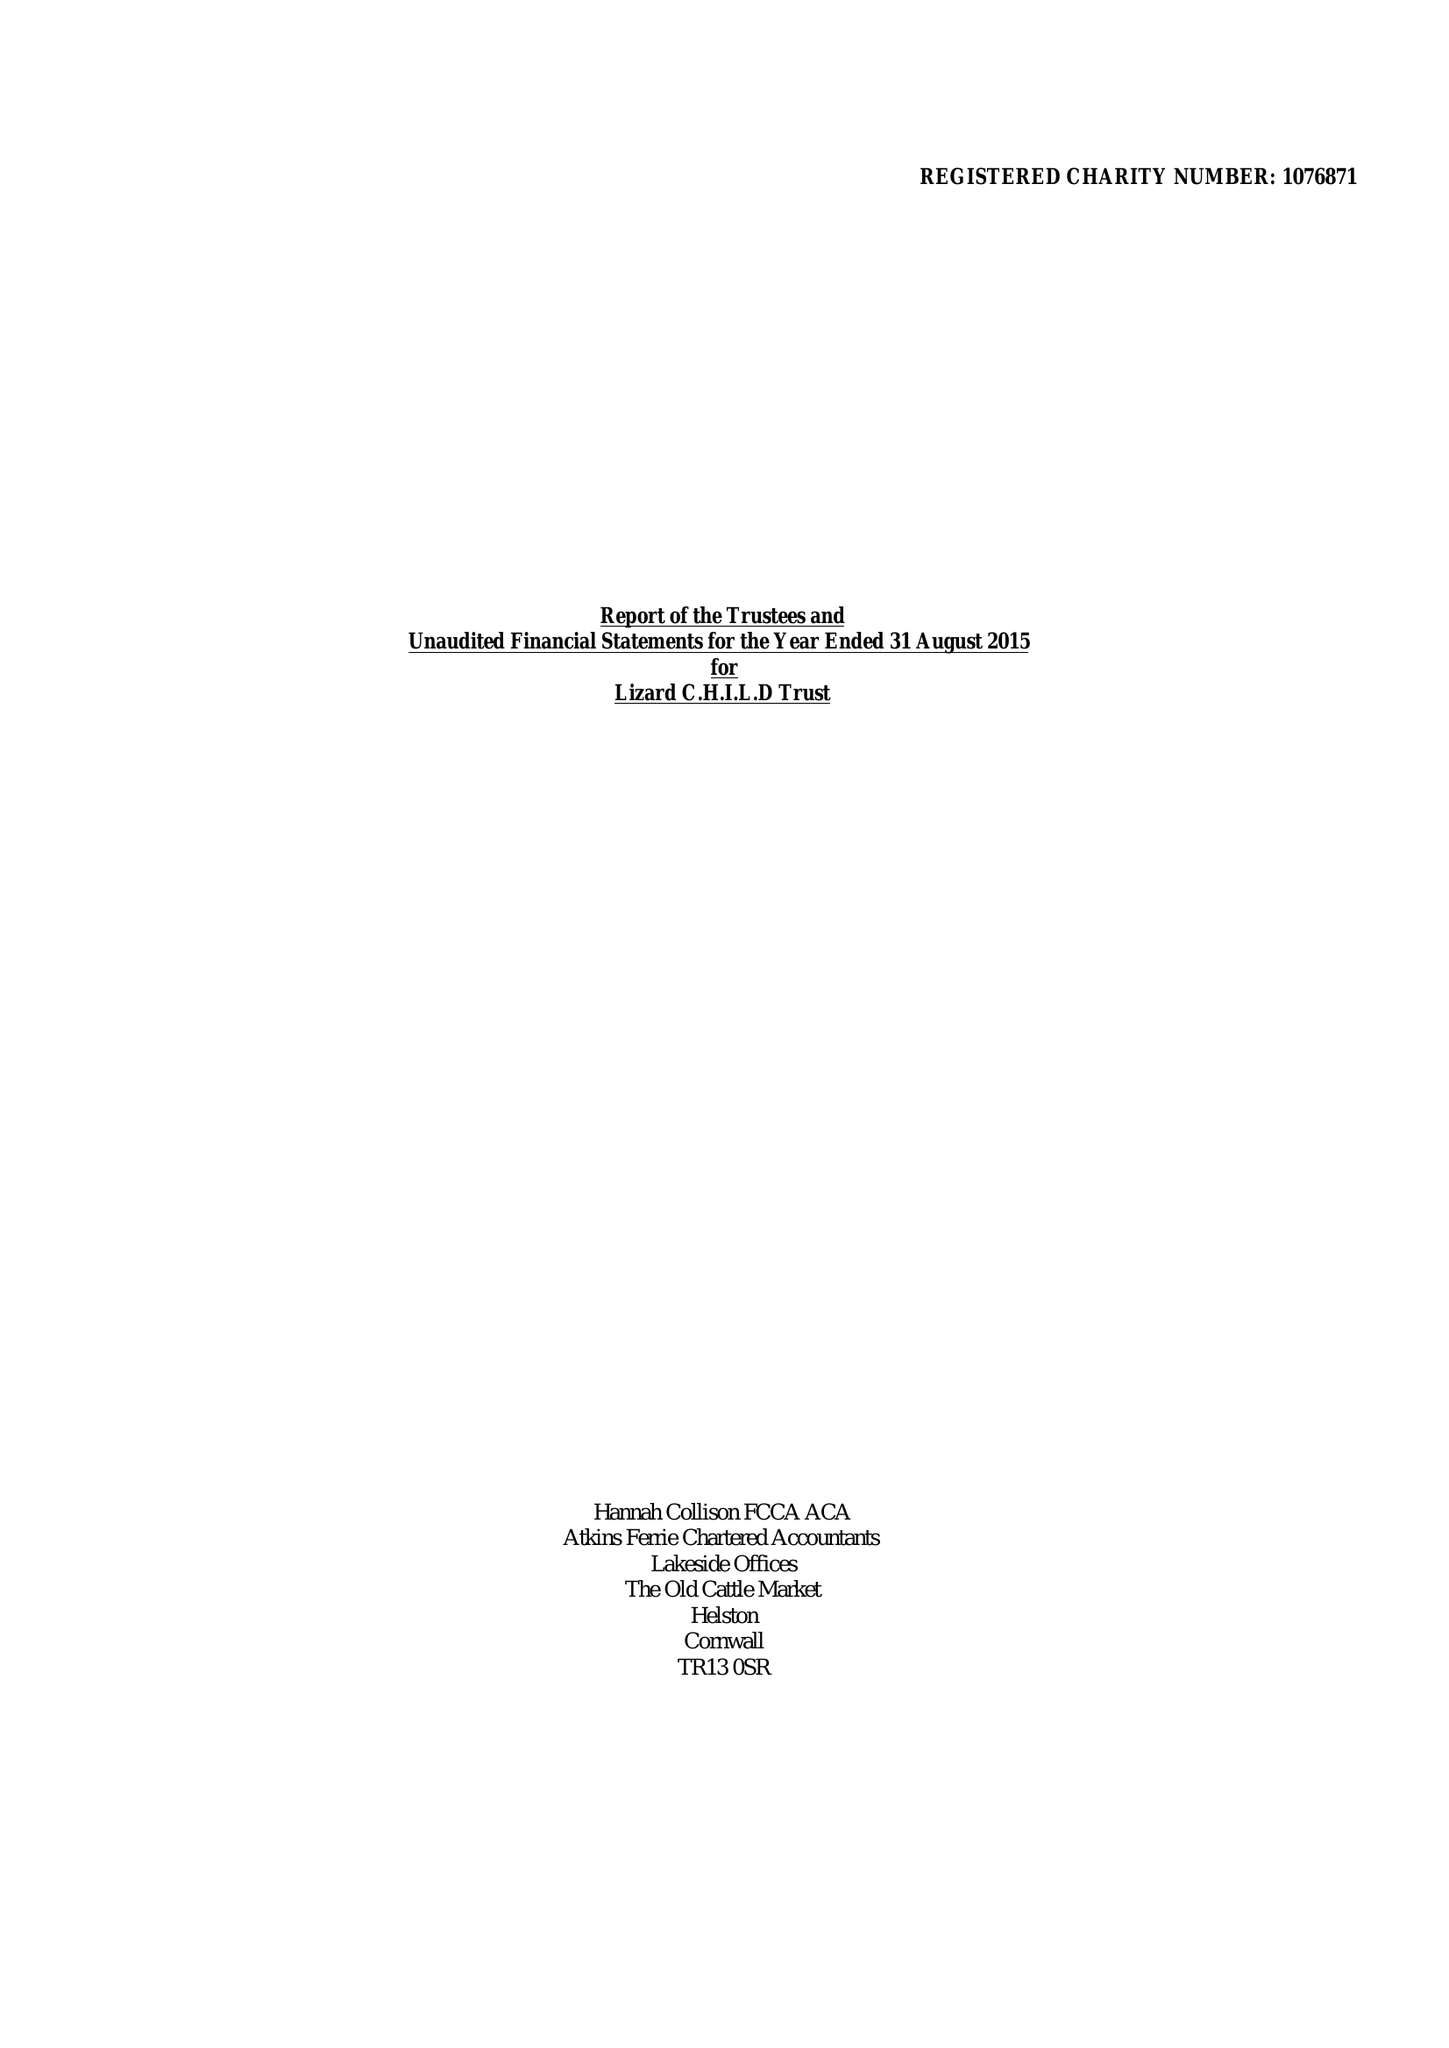What is the value for the charity_number?
Answer the question using a single word or phrase. 1076871 